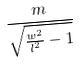Convert formula to latex. <formula><loc_0><loc_0><loc_500><loc_500>\frac { m } { \sqrt { \frac { w ^ { 2 } } { l ^ { 2 } } - 1 } }</formula> 